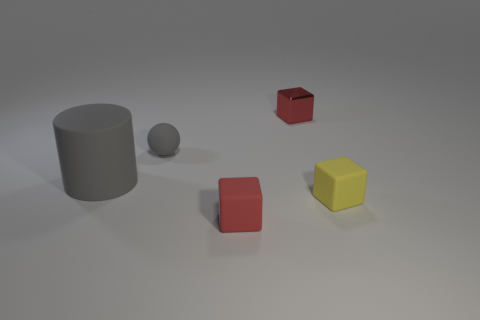Add 4 big red matte things. How many objects exist? 9 Subtract all cubes. How many objects are left? 2 Add 5 small balls. How many small balls are left? 6 Add 4 yellow things. How many yellow things exist? 5 Subtract 0 yellow balls. How many objects are left? 5 Subtract all large things. Subtract all metal blocks. How many objects are left? 3 